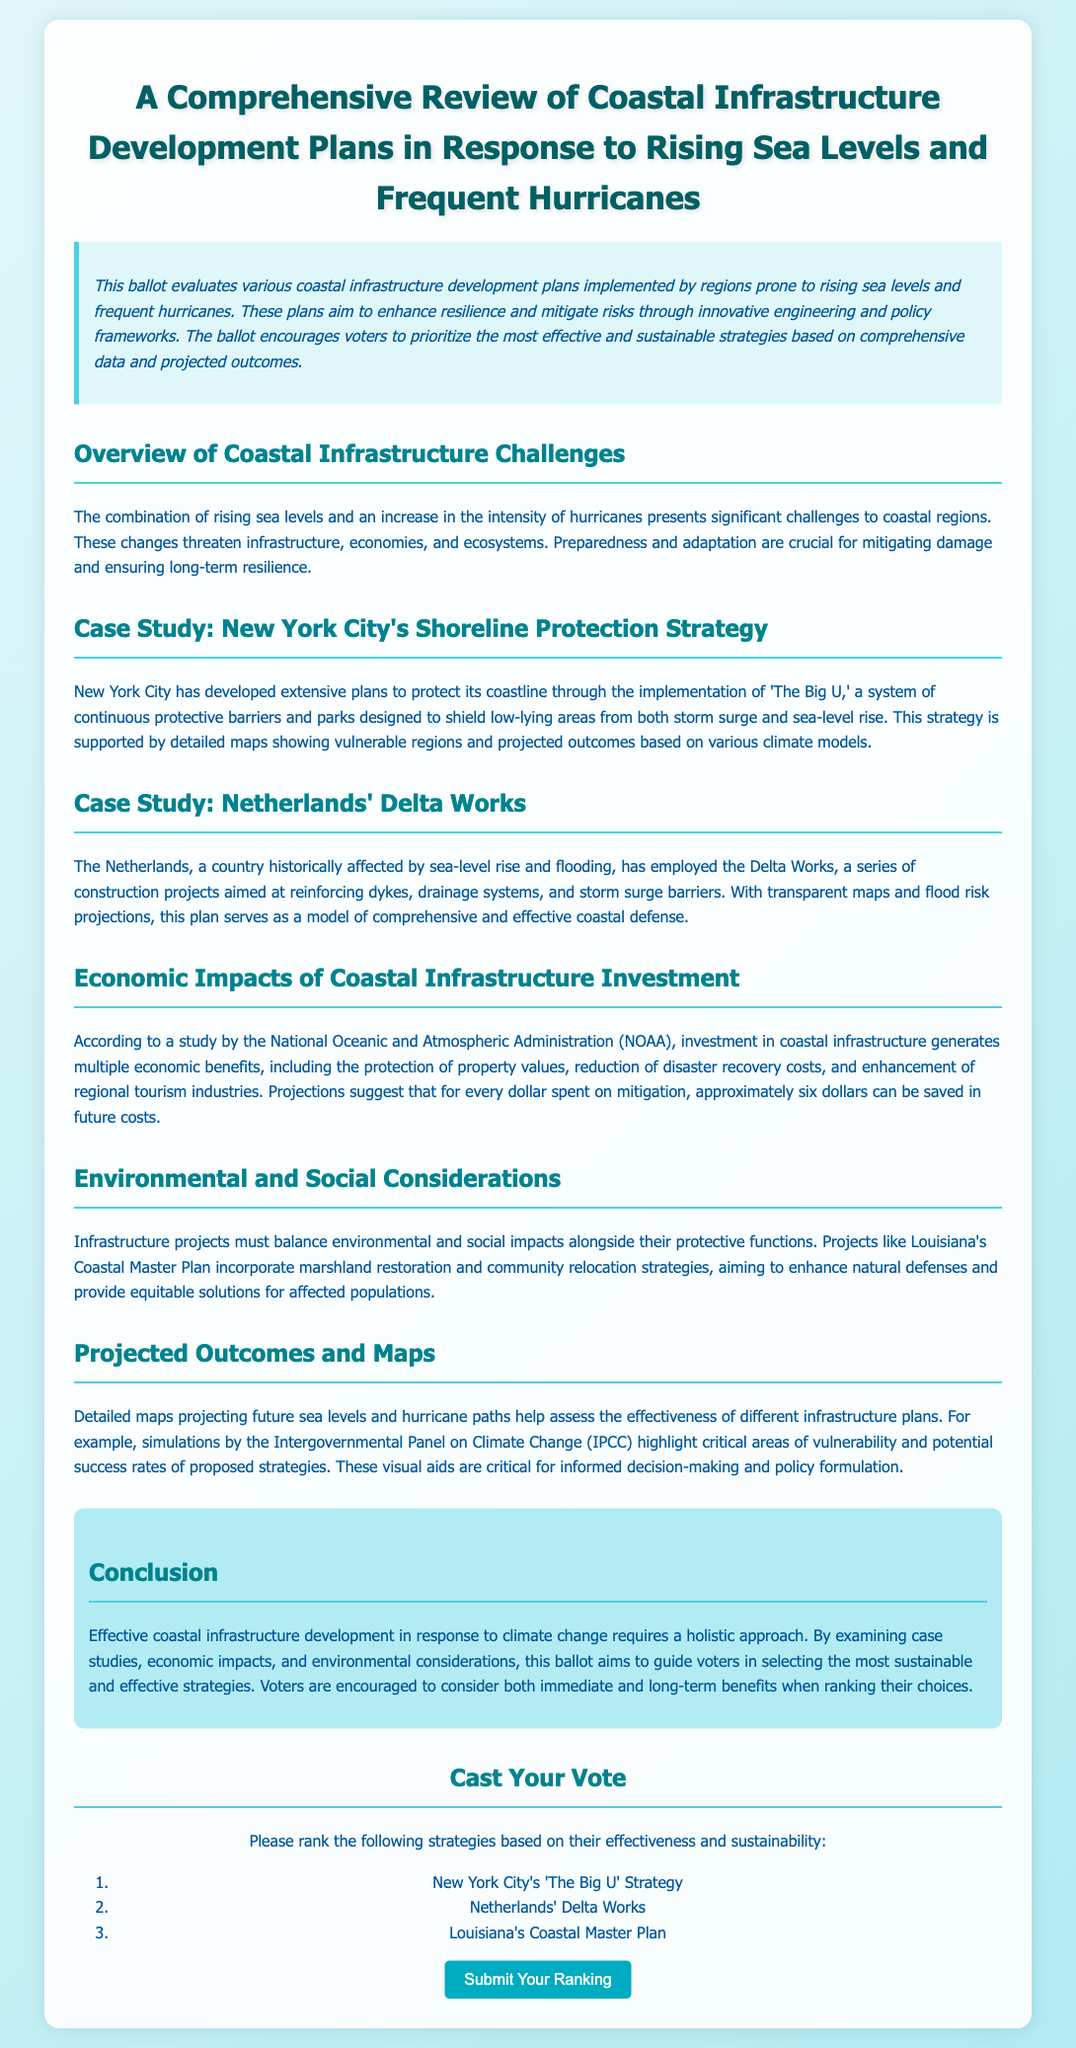What is the title of the ballot? The title is the main heading of the document, indicating its focus on coastal infrastructure.
Answer: A Comprehensive Review of Coastal Infrastructure Development Plans in Response to Rising Sea Levels and Frequent Hurricanes What is 'The Big U'? 'The Big U' is a strategy implemented by New York City to protect its coastline through a system of barriers and parks.
Answer: A system of continuous protective barriers and parks What country is known for the Delta Works? The Delta Works is a series of construction projects aimed at coastal defense, specifically associated with one country.
Answer: Netherlands What economic benefit is mentioned for coastal infrastructure investment? The document states that investment in coastal infrastructure can lead to a specific economic benefit concerning property values.
Answer: Protection of property values How many dollars can be saved for every dollar spent on mitigation? The document provides a projection on the economic returns from investments made in coastal infrastructure.
Answer: Six dollars What does Louisiana's Coastal Master Plan primarily incorporate? This plan integrates environmental considerations by focusing on specific strategies to protect the coast and the community.
Answer: Marshland restoration and community relocation strategies What type of maps are used in projecting future sea levels? The document refers to specific types of visual aids that help in assessing the effectiveness of infrastructure plans.
Answer: Detailed maps What approach is emphasized for effective coastal infrastructure development? The conclusion summarizes the importance of a specific approach to achieve effective coastal infrastructure.
Answer: A holistic approach 